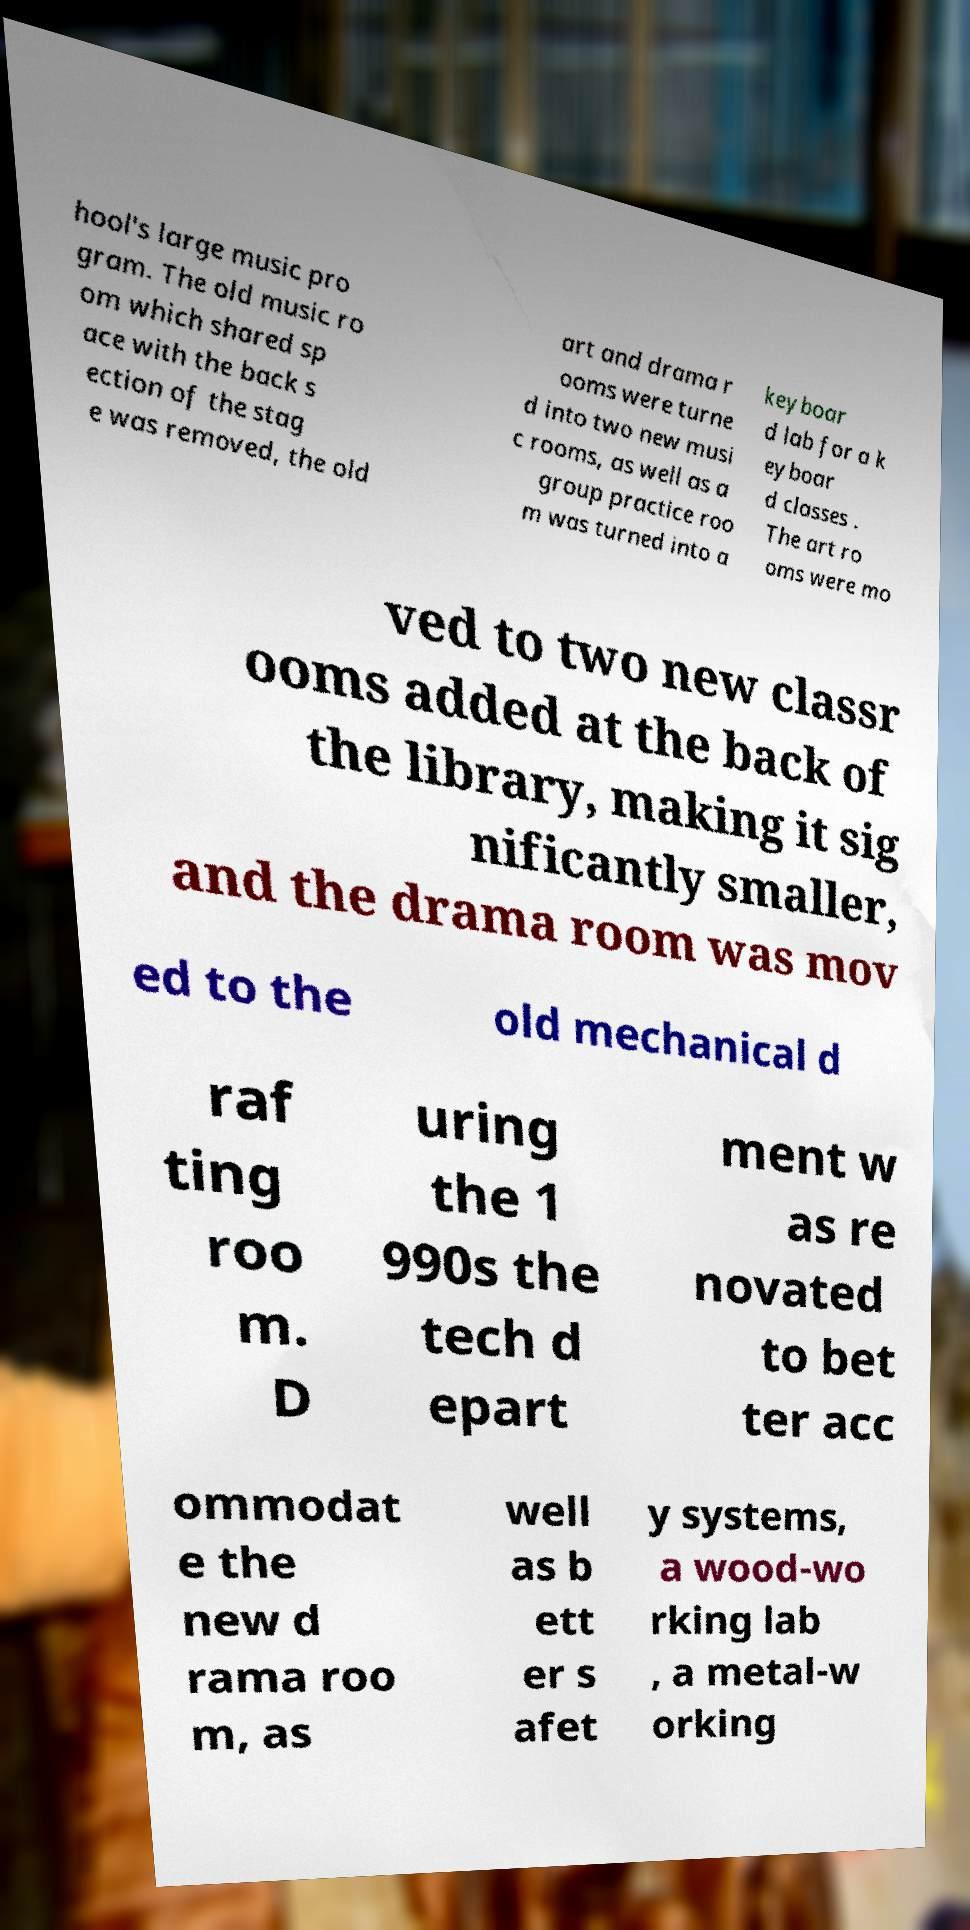Can you accurately transcribe the text from the provided image for me? hool's large music pro gram. The old music ro om which shared sp ace with the back s ection of the stag e was removed, the old art and drama r ooms were turne d into two new musi c rooms, as well as a group practice roo m was turned into a keyboar d lab for a k eyboar d classes . The art ro oms were mo ved to two new classr ooms added at the back of the library, making it sig nificantly smaller, and the drama room was mov ed to the old mechanical d raf ting roo m. D uring the 1 990s the tech d epart ment w as re novated to bet ter acc ommodat e the new d rama roo m, as well as b ett er s afet y systems, a wood-wo rking lab , a metal-w orking 